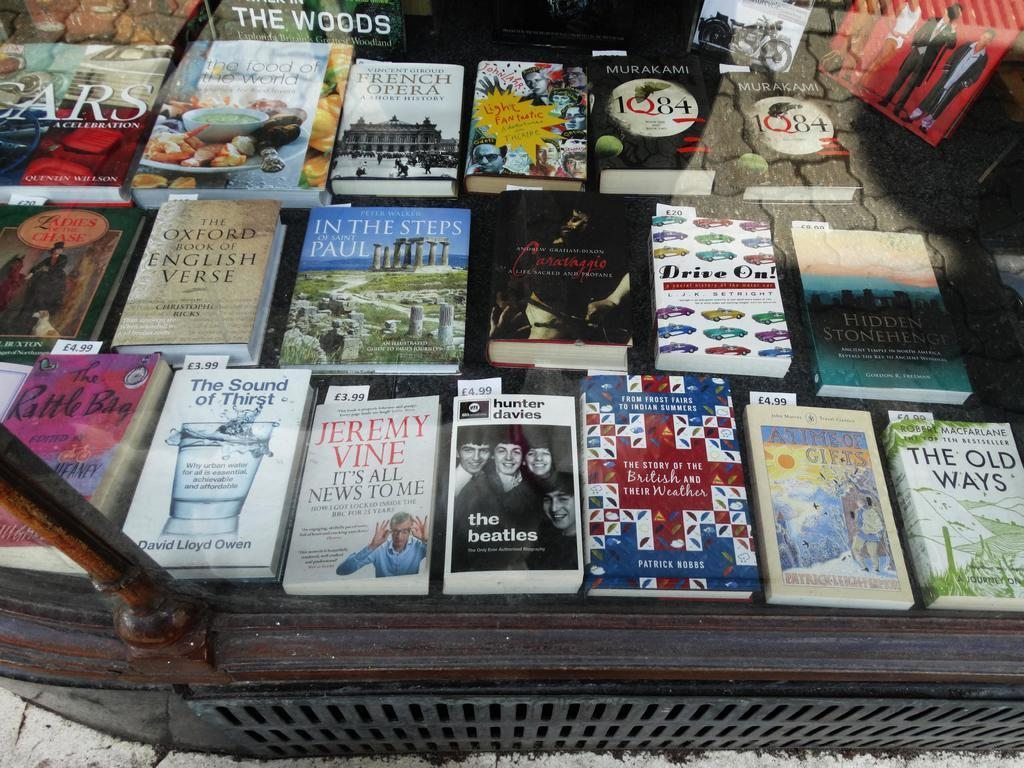What type of furniture is present in the image? There is a table in the image. What items are placed on the table? There are books on the table. What material is visible in the image? Glass is visible in the image. What surface can be seen at the bottom of the image? The ground is visible in the image. What type of zinc can be seen in the image? There is no zinc present in the image. How many clams are visible on the table in the image? There are no clams visible on the table in the image. 